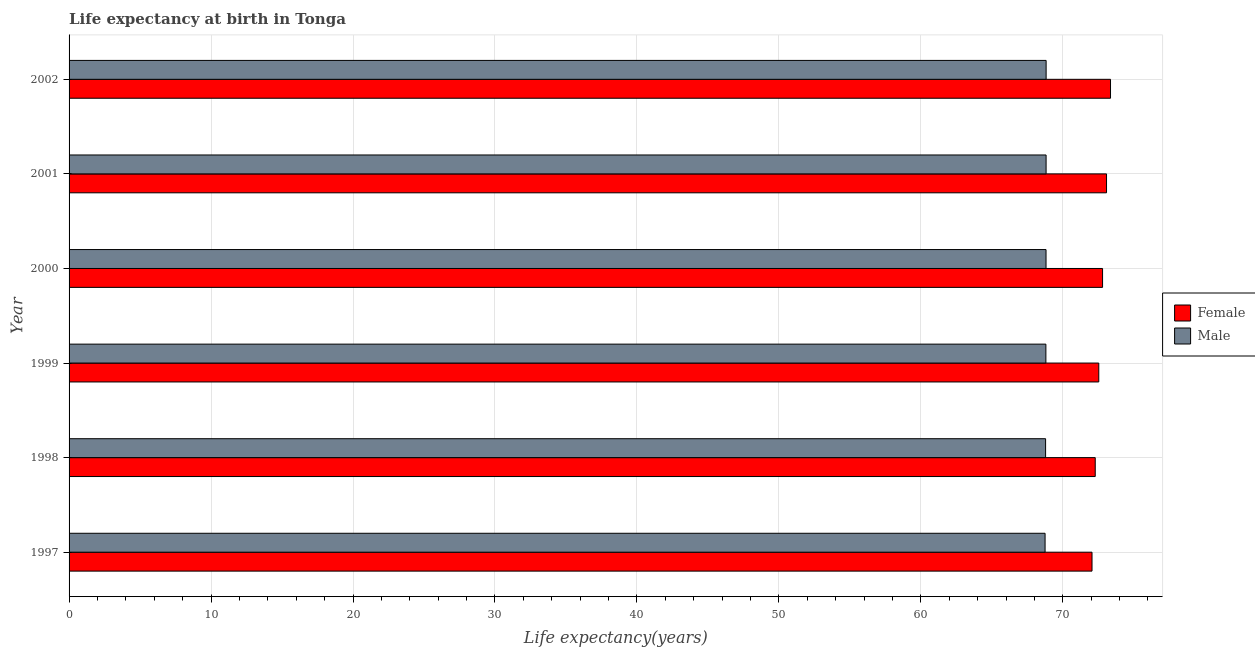How many different coloured bars are there?
Provide a succinct answer. 2. How many groups of bars are there?
Provide a short and direct response. 6. How many bars are there on the 5th tick from the top?
Your answer should be very brief. 2. How many bars are there on the 5th tick from the bottom?
Give a very brief answer. 2. What is the life expectancy(male) in 2001?
Your response must be concise. 68.82. Across all years, what is the maximum life expectancy(male)?
Your response must be concise. 68.82. Across all years, what is the minimum life expectancy(male)?
Give a very brief answer. 68.75. In which year was the life expectancy(male) maximum?
Offer a terse response. 2002. What is the total life expectancy(female) in the graph?
Offer a terse response. 436.11. What is the difference between the life expectancy(female) in 1998 and that in 2000?
Your response must be concise. -0.52. What is the difference between the life expectancy(female) in 1999 and the life expectancy(male) in 2000?
Give a very brief answer. 3.72. What is the average life expectancy(male) per year?
Keep it short and to the point. 68.8. In the year 1998, what is the difference between the life expectancy(female) and life expectancy(male)?
Provide a succinct answer. 3.5. Is the life expectancy(male) in 1998 less than that in 1999?
Give a very brief answer. Yes. What is the difference between the highest and the second highest life expectancy(female)?
Make the answer very short. 0.28. What is the difference between the highest and the lowest life expectancy(male)?
Your answer should be compact. 0.07. In how many years, is the life expectancy(female) greater than the average life expectancy(female) taken over all years?
Ensure brevity in your answer.  3. What does the 1st bar from the bottom in 1998 represents?
Keep it short and to the point. Female. Are all the bars in the graph horizontal?
Provide a short and direct response. Yes. Does the graph contain grids?
Make the answer very short. Yes. How many legend labels are there?
Provide a short and direct response. 2. How are the legend labels stacked?
Your response must be concise. Vertical. What is the title of the graph?
Ensure brevity in your answer.  Life expectancy at birth in Tonga. What is the label or title of the X-axis?
Offer a very short reply. Life expectancy(years). What is the Life expectancy(years) in Female in 1997?
Your answer should be compact. 72.06. What is the Life expectancy(years) of Male in 1997?
Your answer should be compact. 68.75. What is the Life expectancy(years) of Female in 1998?
Provide a succinct answer. 72.28. What is the Life expectancy(years) in Male in 1998?
Your response must be concise. 68.79. What is the Life expectancy(years) of Female in 1999?
Your answer should be very brief. 72.53. What is the Life expectancy(years) of Male in 1999?
Provide a succinct answer. 68.81. What is the Life expectancy(years) of Female in 2000?
Provide a succinct answer. 72.8. What is the Life expectancy(years) of Male in 2000?
Provide a short and direct response. 68.82. What is the Life expectancy(years) of Female in 2001?
Your response must be concise. 73.08. What is the Life expectancy(years) of Male in 2001?
Your answer should be compact. 68.82. What is the Life expectancy(years) of Female in 2002?
Your answer should be very brief. 73.36. What is the Life expectancy(years) in Male in 2002?
Your response must be concise. 68.82. Across all years, what is the maximum Life expectancy(years) in Female?
Give a very brief answer. 73.36. Across all years, what is the maximum Life expectancy(years) of Male?
Keep it short and to the point. 68.82. Across all years, what is the minimum Life expectancy(years) in Female?
Keep it short and to the point. 72.06. Across all years, what is the minimum Life expectancy(years) in Male?
Ensure brevity in your answer.  68.75. What is the total Life expectancy(years) of Female in the graph?
Ensure brevity in your answer.  436.11. What is the total Life expectancy(years) of Male in the graph?
Your answer should be very brief. 412.81. What is the difference between the Life expectancy(years) in Female in 1997 and that in 1998?
Make the answer very short. -0.23. What is the difference between the Life expectancy(years) of Male in 1997 and that in 1998?
Your answer should be compact. -0.04. What is the difference between the Life expectancy(years) in Female in 1997 and that in 1999?
Provide a short and direct response. -0.48. What is the difference between the Life expectancy(years) of Male in 1997 and that in 1999?
Offer a terse response. -0.06. What is the difference between the Life expectancy(years) of Female in 1997 and that in 2000?
Make the answer very short. -0.74. What is the difference between the Life expectancy(years) in Male in 1997 and that in 2000?
Provide a short and direct response. -0.07. What is the difference between the Life expectancy(years) in Female in 1997 and that in 2001?
Offer a terse response. -1.02. What is the difference between the Life expectancy(years) of Male in 1997 and that in 2001?
Ensure brevity in your answer.  -0.07. What is the difference between the Life expectancy(years) of Female in 1997 and that in 2002?
Your answer should be compact. -1.3. What is the difference between the Life expectancy(years) in Male in 1997 and that in 2002?
Your answer should be compact. -0.07. What is the difference between the Life expectancy(years) of Female in 1998 and that in 1999?
Offer a very short reply. -0.25. What is the difference between the Life expectancy(years) of Male in 1998 and that in 1999?
Your answer should be very brief. -0.02. What is the difference between the Life expectancy(years) in Female in 1998 and that in 2000?
Your answer should be compact. -0.52. What is the difference between the Life expectancy(years) in Male in 1998 and that in 2000?
Offer a terse response. -0.03. What is the difference between the Life expectancy(years) of Female in 1998 and that in 2001?
Your answer should be very brief. -0.8. What is the difference between the Life expectancy(years) in Male in 1998 and that in 2001?
Your answer should be compact. -0.04. What is the difference between the Life expectancy(years) of Female in 1998 and that in 2002?
Your answer should be compact. -1.08. What is the difference between the Life expectancy(years) in Male in 1998 and that in 2002?
Provide a succinct answer. -0.04. What is the difference between the Life expectancy(years) of Female in 1999 and that in 2000?
Provide a succinct answer. -0.27. What is the difference between the Life expectancy(years) of Male in 1999 and that in 2000?
Ensure brevity in your answer.  -0.01. What is the difference between the Life expectancy(years) of Female in 1999 and that in 2001?
Keep it short and to the point. -0.55. What is the difference between the Life expectancy(years) in Male in 1999 and that in 2001?
Keep it short and to the point. -0.01. What is the difference between the Life expectancy(years) in Female in 1999 and that in 2002?
Ensure brevity in your answer.  -0.83. What is the difference between the Life expectancy(years) of Male in 1999 and that in 2002?
Give a very brief answer. -0.02. What is the difference between the Life expectancy(years) of Female in 2000 and that in 2001?
Keep it short and to the point. -0.28. What is the difference between the Life expectancy(years) of Male in 2000 and that in 2001?
Your answer should be compact. -0. What is the difference between the Life expectancy(years) in Female in 2000 and that in 2002?
Give a very brief answer. -0.56. What is the difference between the Life expectancy(years) in Male in 2000 and that in 2002?
Keep it short and to the point. -0.01. What is the difference between the Life expectancy(years) in Female in 2001 and that in 2002?
Offer a terse response. -0.28. What is the difference between the Life expectancy(years) in Male in 2001 and that in 2002?
Your answer should be very brief. -0. What is the difference between the Life expectancy(years) in Female in 1997 and the Life expectancy(years) in Male in 1998?
Provide a short and direct response. 3.27. What is the difference between the Life expectancy(years) of Female in 1997 and the Life expectancy(years) of Male in 1999?
Offer a terse response. 3.25. What is the difference between the Life expectancy(years) in Female in 1997 and the Life expectancy(years) in Male in 2000?
Keep it short and to the point. 3.24. What is the difference between the Life expectancy(years) in Female in 1997 and the Life expectancy(years) in Male in 2001?
Ensure brevity in your answer.  3.23. What is the difference between the Life expectancy(years) in Female in 1997 and the Life expectancy(years) in Male in 2002?
Keep it short and to the point. 3.23. What is the difference between the Life expectancy(years) of Female in 1998 and the Life expectancy(years) of Male in 1999?
Your response must be concise. 3.48. What is the difference between the Life expectancy(years) of Female in 1998 and the Life expectancy(years) of Male in 2000?
Offer a terse response. 3.47. What is the difference between the Life expectancy(years) of Female in 1998 and the Life expectancy(years) of Male in 2001?
Ensure brevity in your answer.  3.46. What is the difference between the Life expectancy(years) in Female in 1998 and the Life expectancy(years) in Male in 2002?
Offer a terse response. 3.46. What is the difference between the Life expectancy(years) in Female in 1999 and the Life expectancy(years) in Male in 2000?
Your response must be concise. 3.71. What is the difference between the Life expectancy(years) of Female in 1999 and the Life expectancy(years) of Male in 2001?
Provide a succinct answer. 3.71. What is the difference between the Life expectancy(years) in Female in 1999 and the Life expectancy(years) in Male in 2002?
Your answer should be compact. 3.71. What is the difference between the Life expectancy(years) in Female in 2000 and the Life expectancy(years) in Male in 2001?
Your response must be concise. 3.98. What is the difference between the Life expectancy(years) of Female in 2000 and the Life expectancy(years) of Male in 2002?
Give a very brief answer. 3.98. What is the difference between the Life expectancy(years) of Female in 2001 and the Life expectancy(years) of Male in 2002?
Provide a succinct answer. 4.25. What is the average Life expectancy(years) in Female per year?
Give a very brief answer. 72.69. What is the average Life expectancy(years) of Male per year?
Offer a terse response. 68.8. In the year 1997, what is the difference between the Life expectancy(years) in Female and Life expectancy(years) in Male?
Your answer should be very brief. 3.31. In the year 1998, what is the difference between the Life expectancy(years) of Female and Life expectancy(years) of Male?
Your answer should be compact. 3.5. In the year 1999, what is the difference between the Life expectancy(years) in Female and Life expectancy(years) in Male?
Offer a terse response. 3.73. In the year 2000, what is the difference between the Life expectancy(years) of Female and Life expectancy(years) of Male?
Give a very brief answer. 3.98. In the year 2001, what is the difference between the Life expectancy(years) in Female and Life expectancy(years) in Male?
Give a very brief answer. 4.26. In the year 2002, what is the difference between the Life expectancy(years) of Female and Life expectancy(years) of Male?
Provide a succinct answer. 4.54. What is the ratio of the Life expectancy(years) of Female in 1997 to that in 1998?
Offer a very short reply. 1. What is the ratio of the Life expectancy(years) of Female in 1997 to that in 1999?
Offer a very short reply. 0.99. What is the ratio of the Life expectancy(years) in Male in 1997 to that in 1999?
Provide a short and direct response. 1. What is the ratio of the Life expectancy(years) of Female in 1997 to that in 2001?
Offer a terse response. 0.99. What is the ratio of the Life expectancy(years) in Male in 1997 to that in 2001?
Your response must be concise. 1. What is the ratio of the Life expectancy(years) in Female in 1997 to that in 2002?
Offer a terse response. 0.98. What is the ratio of the Life expectancy(years) in Female in 1998 to that in 2001?
Offer a terse response. 0.99. What is the ratio of the Life expectancy(years) of Male in 1998 to that in 2001?
Provide a short and direct response. 1. What is the ratio of the Life expectancy(years) in Male in 1998 to that in 2002?
Your response must be concise. 1. What is the ratio of the Life expectancy(years) of Male in 1999 to that in 2000?
Give a very brief answer. 1. What is the ratio of the Life expectancy(years) of Female in 1999 to that in 2001?
Your answer should be compact. 0.99. What is the ratio of the Life expectancy(years) in Male in 1999 to that in 2001?
Ensure brevity in your answer.  1. What is the ratio of the Life expectancy(years) of Female in 1999 to that in 2002?
Provide a succinct answer. 0.99. What is the ratio of the Life expectancy(years) in Male in 2000 to that in 2002?
Provide a succinct answer. 1. What is the ratio of the Life expectancy(years) in Male in 2001 to that in 2002?
Offer a terse response. 1. What is the difference between the highest and the second highest Life expectancy(years) of Female?
Your answer should be compact. 0.28. What is the difference between the highest and the second highest Life expectancy(years) of Male?
Offer a terse response. 0. What is the difference between the highest and the lowest Life expectancy(years) in Female?
Your response must be concise. 1.3. What is the difference between the highest and the lowest Life expectancy(years) in Male?
Give a very brief answer. 0.07. 